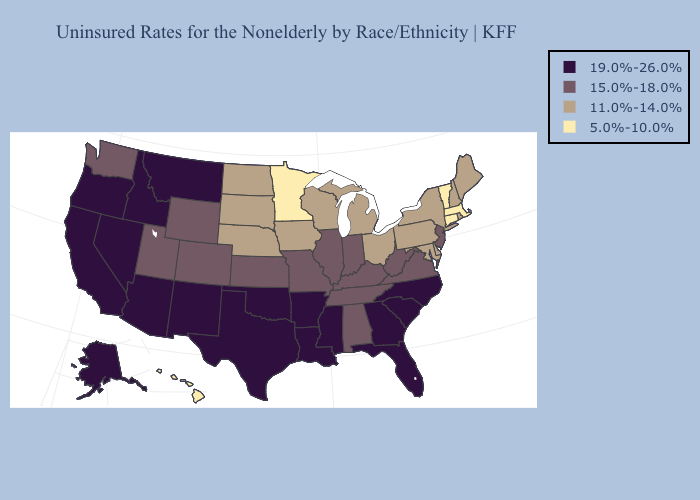Does Alaska have the same value as California?
Give a very brief answer. Yes. What is the highest value in states that border Texas?
Be succinct. 19.0%-26.0%. What is the lowest value in the MidWest?
Answer briefly. 5.0%-10.0%. Does Rhode Island have a lower value than Michigan?
Short answer required. No. Does New Jersey have the highest value in the Northeast?
Keep it brief. Yes. Among the states that border New Hampshire , does Maine have the highest value?
Write a very short answer. Yes. Does the first symbol in the legend represent the smallest category?
Answer briefly. No. Name the states that have a value in the range 11.0%-14.0%?
Answer briefly. Delaware, Iowa, Maine, Maryland, Michigan, Nebraska, New Hampshire, New York, North Dakota, Ohio, Pennsylvania, Rhode Island, South Dakota, Wisconsin. Does the map have missing data?
Answer briefly. No. Name the states that have a value in the range 11.0%-14.0%?
Keep it brief. Delaware, Iowa, Maine, Maryland, Michigan, Nebraska, New Hampshire, New York, North Dakota, Ohio, Pennsylvania, Rhode Island, South Dakota, Wisconsin. Is the legend a continuous bar?
Quick response, please. No. What is the highest value in the USA?
Short answer required. 19.0%-26.0%. Name the states that have a value in the range 5.0%-10.0%?
Keep it brief. Connecticut, Hawaii, Massachusetts, Minnesota, Vermont. What is the highest value in states that border Ohio?
Concise answer only. 15.0%-18.0%. What is the value of Delaware?
Answer briefly. 11.0%-14.0%. 